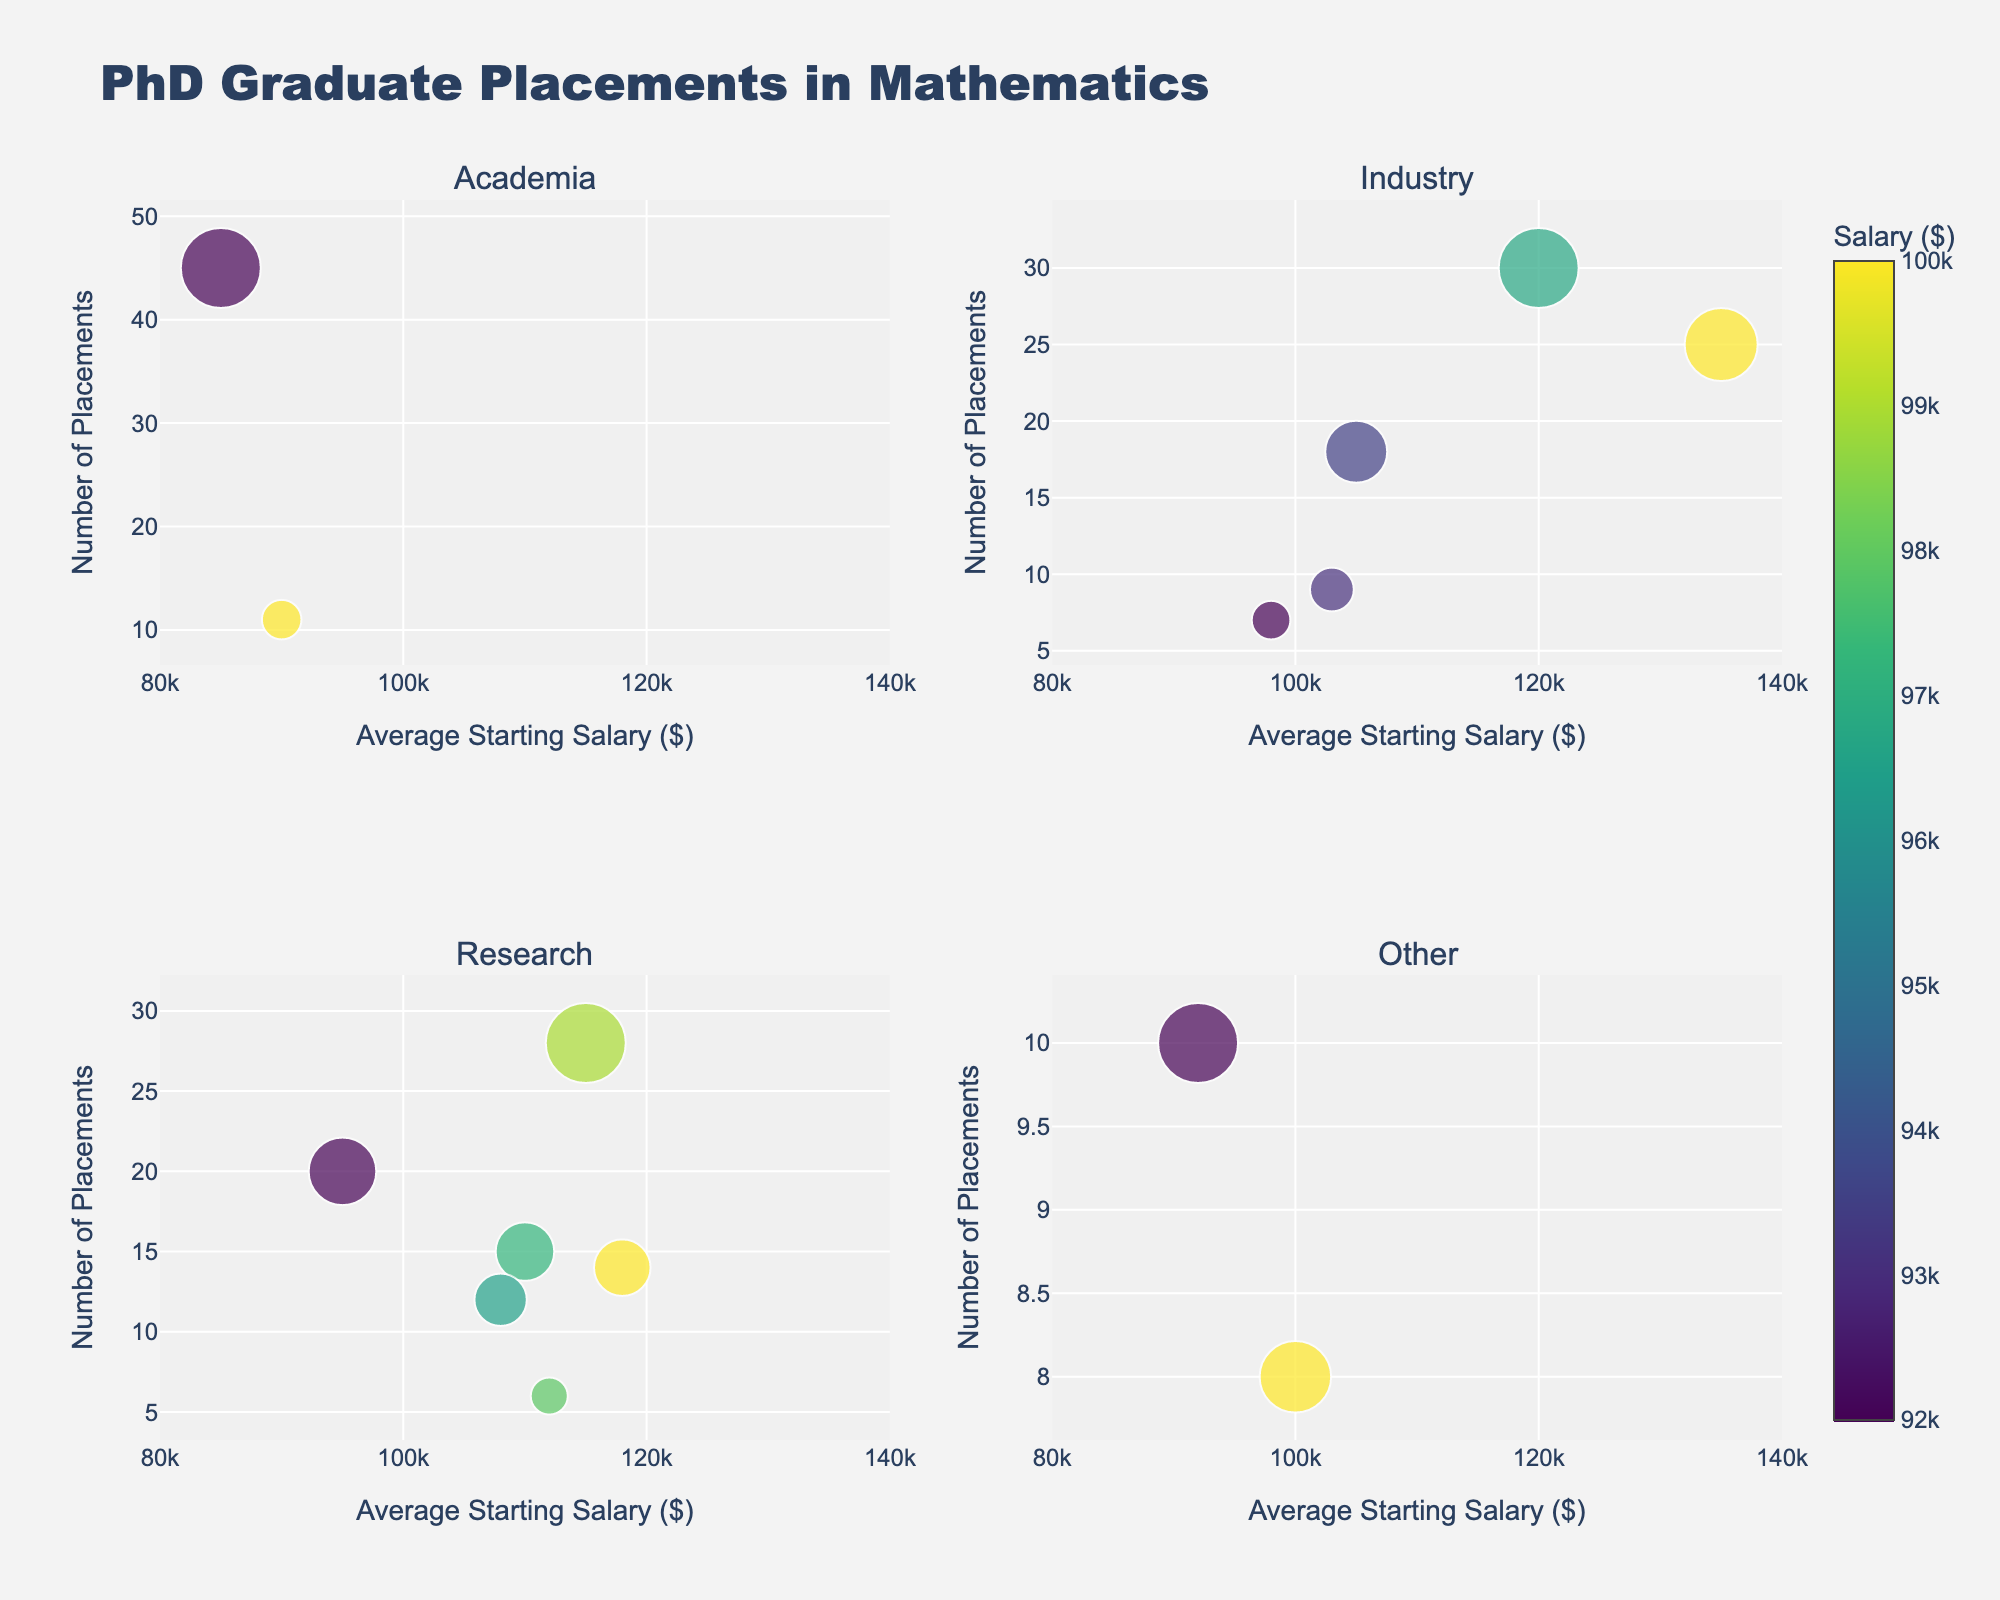Which university has the highest number of placements in the Tech Industry? Look at the bubble in the Industry subplot with the label 'Tech Industry'. The label corresponding to the biggest bubble with 'Tech Industry' is 'Stanford'.
Answer: Stanford What is the range of the average starting salary displayed in the plots? Look at the x-axis labels of all the subplots. The minimum salary range starts at $80,000 and the maximum goes to $140,000.
Answer: $80,000 to $140,000 How many placements does Yale have in the Government sector? Look for the bubble labeled 'Yale' in the Other subplot. It states 'Yale <br>Government' with the number of placements clearly visible as '10'.
Answer: 10 What sector has the highest average starting salary in the chart? Identify the highest point on the x-axis across all subplots. The highest label is in the Industry subplot with 'Finance' having $135,000.
Answer: Finance What is the average number of placements for universities in the Research Institutes sector? Identify the bubbles in the Research subplot labeled 'Research Institutes', which corresponds to Princeton. The number of placements is 20. Since it is the only one, the average is 20.
Answer: 20 How do the placement numbers for Data Science compare to those for Consulting? Identify their respective bubbles in the Research and Industry subplots. UC Berkeley has 28 placements in Data Science, and University of Chicago has 18 placements in Consulting. Data Science has 10 more placements than Consulting.
Answer: Data Science has 10 more placements Which university has the lowest average starting salary in Academia? Look in the Academia subplot and find the bubble labeled with the lowest starting salary on the x-axis. University of Cambridge has the lowest average starting salary ($90,000).
Answer: University of Cambridge Between Aerospace and Pharmaceuticals sectors, which has the higher number of placements and what are their respective salaries? Find the bubbles for Aerospace and Pharmaceuticals in the Research subplot. Aerospace (Caltech) has 15 placements with an average salary of $110,000 while Pharmaceuticals (ETH Zurich) has 6 placements with an average salary of $112,000. Aerospace has more placements.
Answer: Aerospace (15 placements, $110,000), Pharmaceuticals (6 placements, $112,000) How many sectors does the top-left subplot represent, and which one has the highest starting salary? The top-left subplot represents the 'Academia' sector. It contains two sectors: Academia and Education Technology. The highest average starting salary in this subplot is $85,000 from MIT under Academia.
Answer: 2 sectors, MIT in Academia with $85,000 